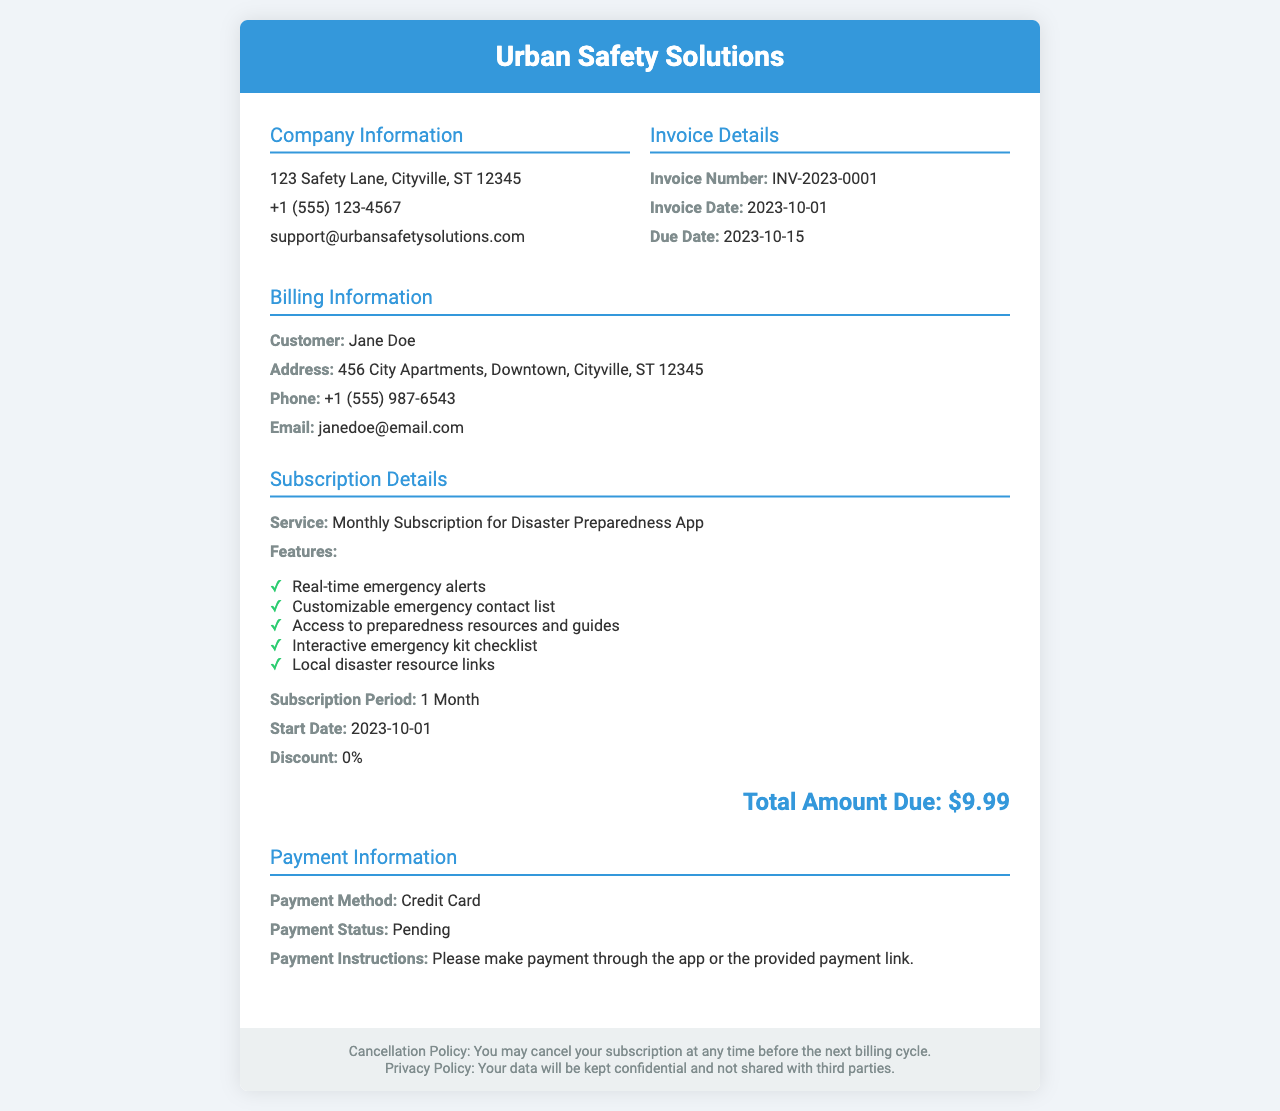What is the invoice number? The invoice number is specifically mentioned in the document under Invoice Details.
Answer: INV-2023-0001 What is the total amount due? The total amount due is indicated at the bottom of the Subscription Details section.
Answer: $9.99 Who is the customer? The customer's name is provided in the Billing Information section.
Answer: Jane Doe What is the start date of the subscription? The start date of the subscription is noted in the Subscription Details section.
Answer: 2023-10-01 What features are included in the subscription? The subscription features are listed in a bullet format in the Subscription Details section.
Answer: Real-time emergency alerts, Customizable emergency contact list, Access to preparedness resources and guides, Interactive emergency kit checklist, Local disaster resource links What is the payment method? The payment method used for the subscription is stated in the Payment Information section.
Answer: Credit Card What is the payment status? The payment status reflects the current state of the payment and is documented in Payment Information.
Answer: Pending What is the due date for the invoice? The due date is specified under Invoice Details, indicating when payment must be made.
Answer: 2023-10-15 What is Urban Safety Solutions' contact email? The contact email for Urban Safety Solutions is given in the Company Information section.
Answer: support@urbansafetysolutions.com 